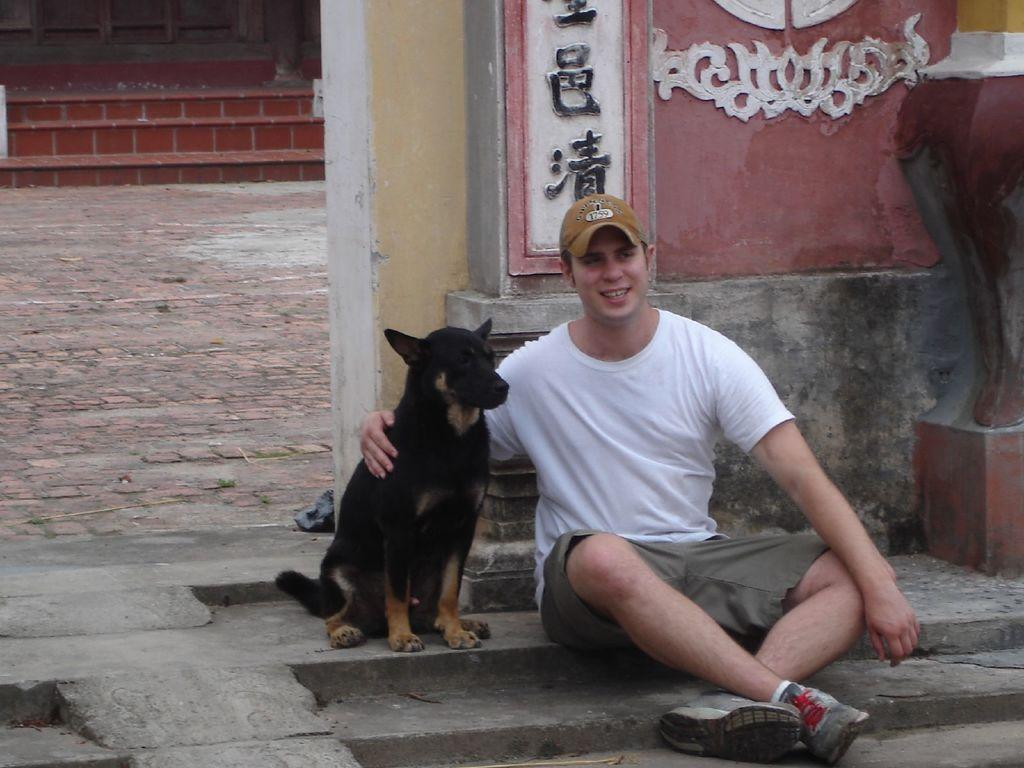Who is present in the image? There is a man in the image. What is the man wearing? The man is wearing a white t-shirt. What is the man's position in the image? The man is sitting on the floor. What other living creature is in the image? There is a dog in the image. What is the color of the dog? The dog is black. How is the dog positioned in relation to the man? The dog is sitting beside the man. What architectural feature can be seen in the image? There are steps visible in the image. What type of sugar is being used to rake the land in the image? There is no sugar or rake present in the image, and no land is being raked. 